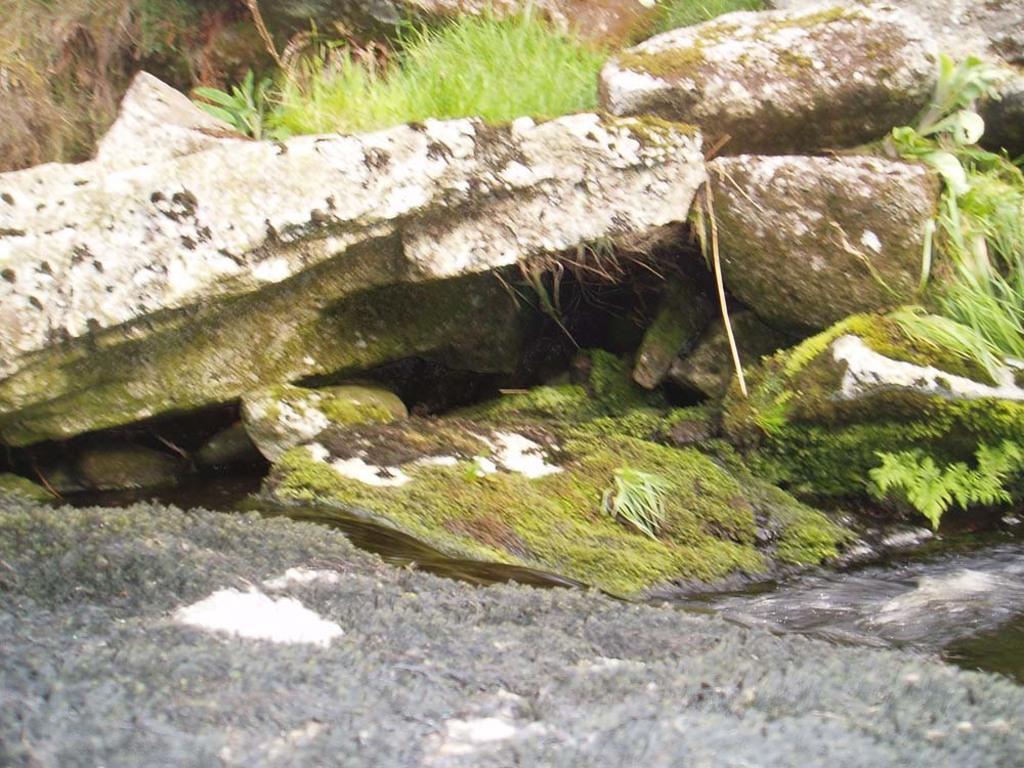Describe this image in one or two sentences. As we can see in the image there are rocks and grass. 